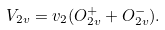Convert formula to latex. <formula><loc_0><loc_0><loc_500><loc_500>V _ { 2 v } = v _ { 2 } ( O _ { 2 v } ^ { + } + O _ { 2 v } ^ { - } ) .</formula> 